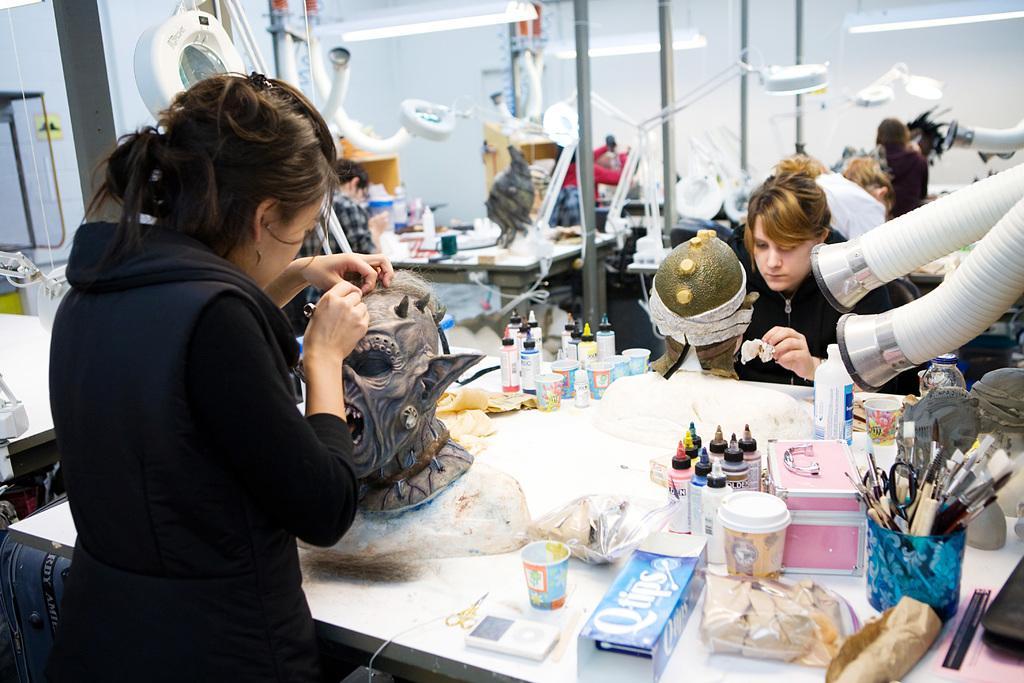Describe this image in one or two sentences. This image is taken indoors. At the bottom of the image there is a table with many things on it. On the left side of the image a woman is standing on the floor and she is carving and there is a table. On the right side of the image there are a few pipes and a few people are sitting on the chairs. In the background there is a wall and there is a table with many things on it. 